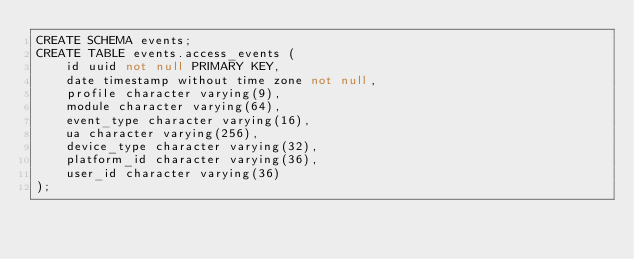Convert code to text. <code><loc_0><loc_0><loc_500><loc_500><_SQL_>CREATE SCHEMA events;
CREATE TABLE events.access_events (
    id uuid not null PRIMARY KEY,
    date timestamp without time zone not null,
    profile character varying(9),
    module character varying(64),
    event_type character varying(16),
    ua character varying(256),
    device_type character varying(32),
    platform_id character varying(36),
    user_id character varying(36)
);</code> 